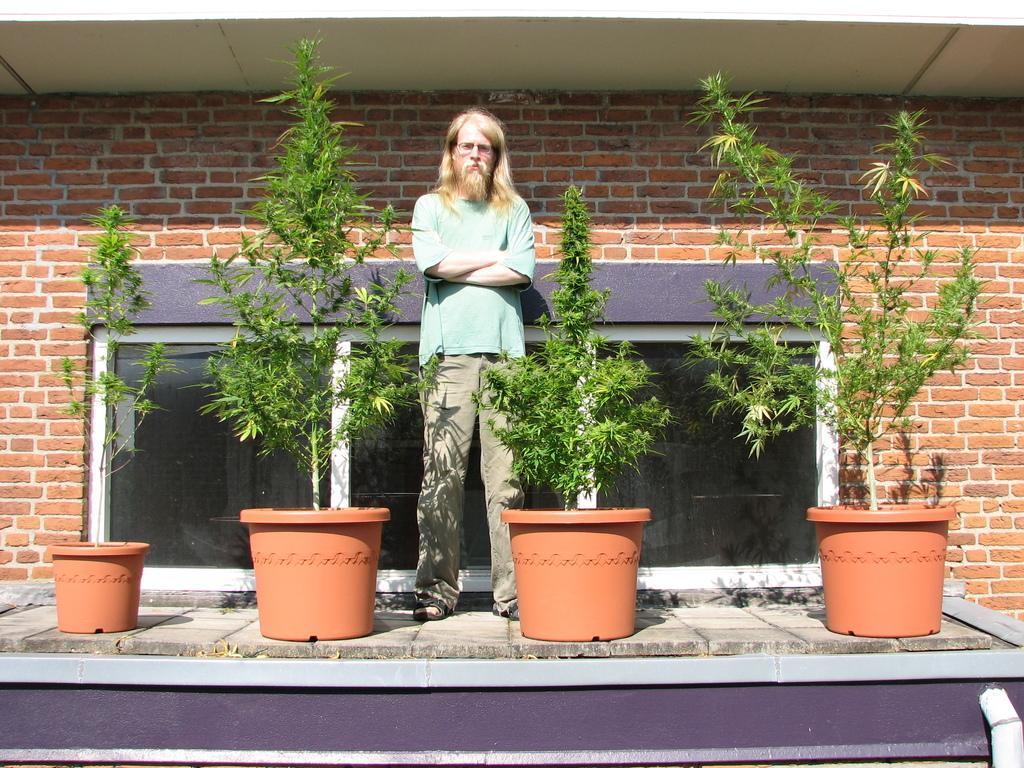In one or two sentences, can you explain what this image depicts? In this picture there is a man standing. In the foreground there are plants in the pots. At the back there is a window and there is a wall. At the bottom right it looks like a pipe. 